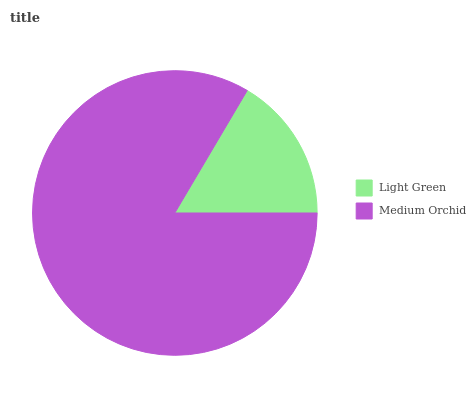Is Light Green the minimum?
Answer yes or no. Yes. Is Medium Orchid the maximum?
Answer yes or no. Yes. Is Medium Orchid the minimum?
Answer yes or no. No. Is Medium Orchid greater than Light Green?
Answer yes or no. Yes. Is Light Green less than Medium Orchid?
Answer yes or no. Yes. Is Light Green greater than Medium Orchid?
Answer yes or no. No. Is Medium Orchid less than Light Green?
Answer yes or no. No. Is Medium Orchid the high median?
Answer yes or no. Yes. Is Light Green the low median?
Answer yes or no. Yes. Is Light Green the high median?
Answer yes or no. No. Is Medium Orchid the low median?
Answer yes or no. No. 